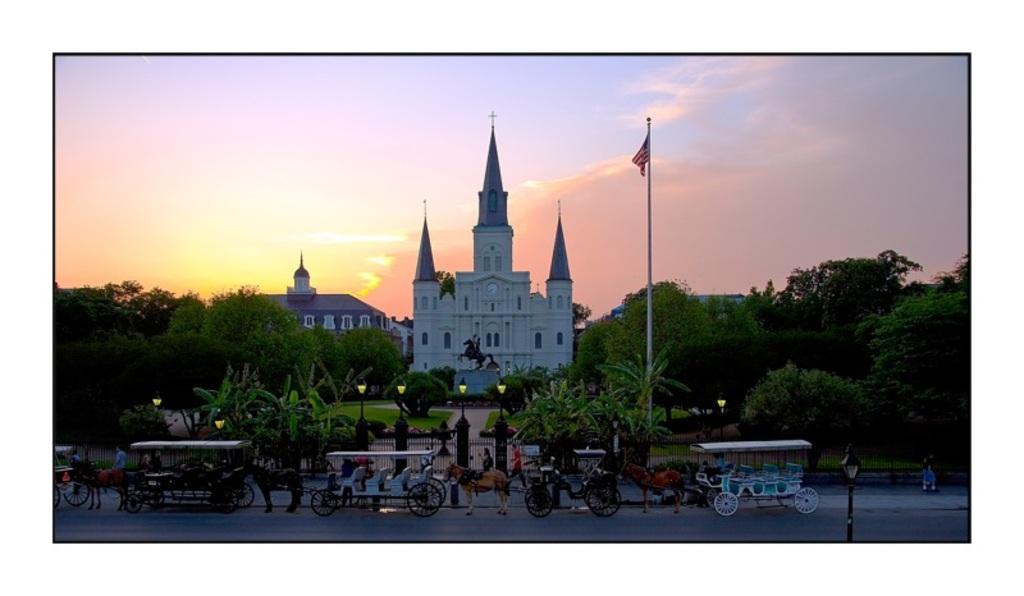In one or two sentences, can you explain what this image depicts? In this image in the center there are some buildings and church, and at the bottom there are some vehicles, horses, gate, pole, flag and some trees and plants. At the bottom there is a road, and at the top of the image there is sky. 